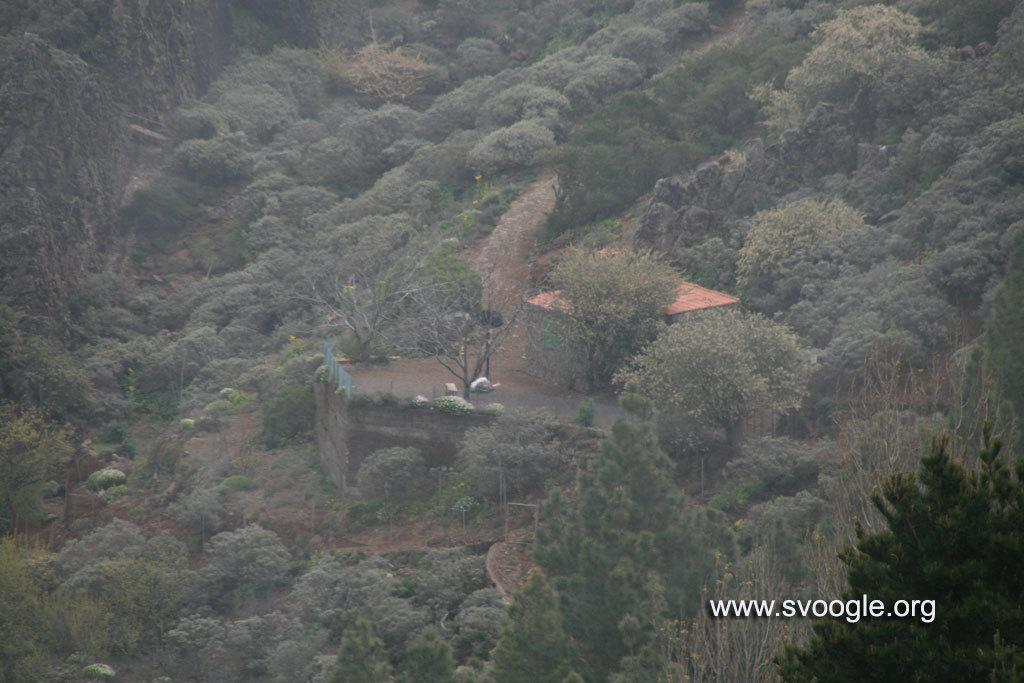What is the main subject of the image? The main subject of the image is a building on a mountain. What can be seen around the building? There are trees around the building. Where is the text or image located in the image? The text or image is at the right side bottom of the image. How many clams are visible on the mountain in the image? There are no clams visible on the mountain in the image. What type of apples are growing on the trees around the building? There are no apples mentioned or visible in the image; only trees are mentioned. 